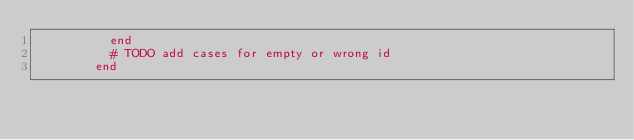<code> <loc_0><loc_0><loc_500><loc_500><_Ruby_>          end
          # TODO add cases for empty or wrong id
        end
</code> 